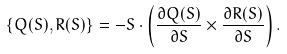<formula> <loc_0><loc_0><loc_500><loc_500>\{ Q ( { S } ) , R ( { S } ) \} = - { S } \cdot \left ( \frac { \partial Q ( { S } ) } { \partial { S } } \times \frac { \partial R ( { S } ) } { \partial { S } } \right ) .</formula> 